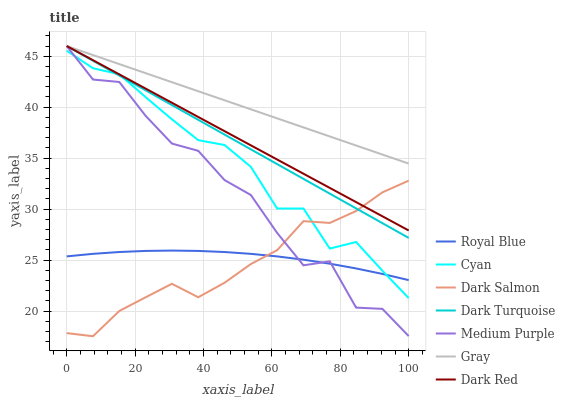Does Dark Salmon have the minimum area under the curve?
Answer yes or no. Yes. Does Gray have the maximum area under the curve?
Answer yes or no. Yes. Does Dark Turquoise have the minimum area under the curve?
Answer yes or no. No. Does Dark Turquoise have the maximum area under the curve?
Answer yes or no. No. Is Dark Turquoise the smoothest?
Answer yes or no. Yes. Is Medium Purple the roughest?
Answer yes or no. Yes. Is Dark Salmon the smoothest?
Answer yes or no. No. Is Dark Salmon the roughest?
Answer yes or no. No. Does Dark Salmon have the lowest value?
Answer yes or no. Yes. Does Dark Turquoise have the lowest value?
Answer yes or no. No. Does Dark Red have the highest value?
Answer yes or no. Yes. Does Dark Salmon have the highest value?
Answer yes or no. No. Is Royal Blue less than Gray?
Answer yes or no. Yes. Is Gray greater than Dark Salmon?
Answer yes or no. Yes. Does Dark Red intersect Dark Turquoise?
Answer yes or no. Yes. Is Dark Red less than Dark Turquoise?
Answer yes or no. No. Is Dark Red greater than Dark Turquoise?
Answer yes or no. No. Does Royal Blue intersect Gray?
Answer yes or no. No. 